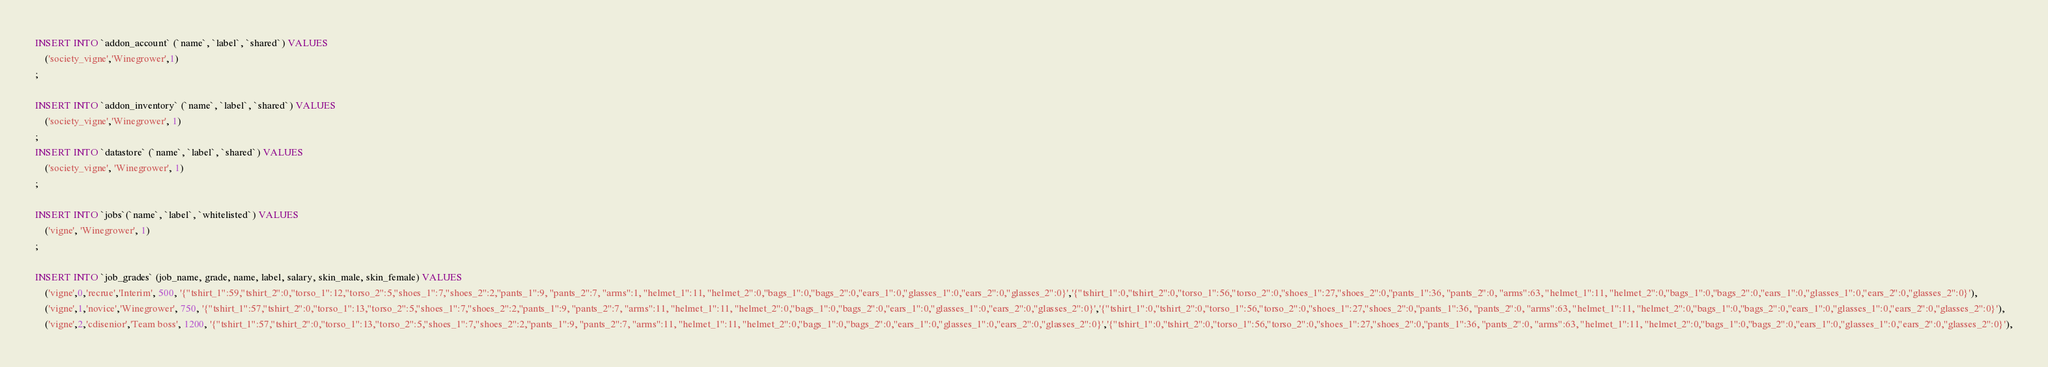Convert code to text. <code><loc_0><loc_0><loc_500><loc_500><_SQL_>INSERT INTO `addon_account` (`name`, `label`, `shared`) VALUES
	('society_vigne','Winegrower',1)
;

INSERT INTO `addon_inventory` (`name`, `label`, `shared`) VALUES
	('society_vigne','Winegrower', 1)
;
INSERT INTO `datastore` (`name`, `label`, `shared`) VALUES
	('society_vigne', 'Winegrower', 1)
;

INSERT INTO `jobs`(`name`, `label`, `whitelisted`) VALUES
	('vigne', 'Winegrower', 1)
;

INSERT INTO `job_grades` (job_name, grade, name, label, salary, skin_male, skin_female) VALUES
	('vigne',0,'recrue','Interim', 500, '{"tshirt_1":59,"tshirt_2":0,"torso_1":12,"torso_2":5,"shoes_1":7,"shoes_2":2,"pants_1":9, "pants_2":7, "arms":1, "helmet_1":11, "helmet_2":0,"bags_1":0,"bags_2":0,"ears_1":0,"glasses_1":0,"ears_2":0,"glasses_2":0}','{"tshirt_1":0,"tshirt_2":0,"torso_1":56,"torso_2":0,"shoes_1":27,"shoes_2":0,"pants_1":36, "pants_2":0, "arms":63, "helmet_1":11, "helmet_2":0,"bags_1":0,"bags_2":0,"ears_1":0,"glasses_1":0,"ears_2":0,"glasses_2":0}'),
	('vigne',1,'novice','Winegrower', 750, '{"tshirt_1":57,"tshirt_2":0,"torso_1":13,"torso_2":5,"shoes_1":7,"shoes_2":2,"pants_1":9, "pants_2":7, "arms":11, "helmet_1":11, "helmet_2":0,"bags_1":0,"bags_2":0,"ears_1":0,"glasses_1":0,"ears_2":0,"glasses_2":0}','{"tshirt_1":0,"tshirt_2":0,"torso_1":56,"torso_2":0,"shoes_1":27,"shoes_2":0,"pants_1":36, "pants_2":0, "arms":63, "helmet_1":11, "helmet_2":0,"bags_1":0,"bags_2":0,"ears_1":0,"glasses_1":0,"ears_2":0,"glasses_2":0}'),
	('vigne',2,'cdisenior','Team boss', 1200, '{"tshirt_1":57,"tshirt_2":0,"torso_1":13,"torso_2":5,"shoes_1":7,"shoes_2":2,"pants_1":9, "pants_2":7, "arms":11, "helmet_1":11, "helmet_2":0,"bags_1":0,"bags_2":0,"ears_1":0,"glasses_1":0,"ears_2":0,"glasses_2":0}','{"tshirt_1":0,"tshirt_2":0,"torso_1":56,"torso_2":0,"shoes_1":27,"shoes_2":0,"pants_1":36, "pants_2":0, "arms":63, "helmet_1":11, "helmet_2":0,"bags_1":0,"bags_2":0,"ears_1":0,"glasses_1":0,"ears_2":0,"glasses_2":0}'),</code> 